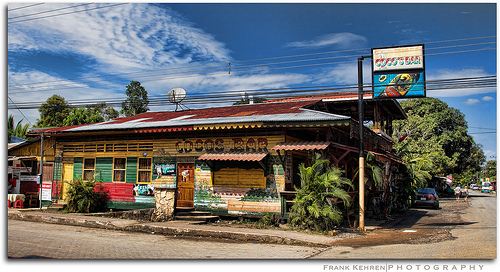<image>
Can you confirm if the sign is on the building? Yes. Looking at the image, I can see the sign is positioned on top of the building, with the building providing support. 